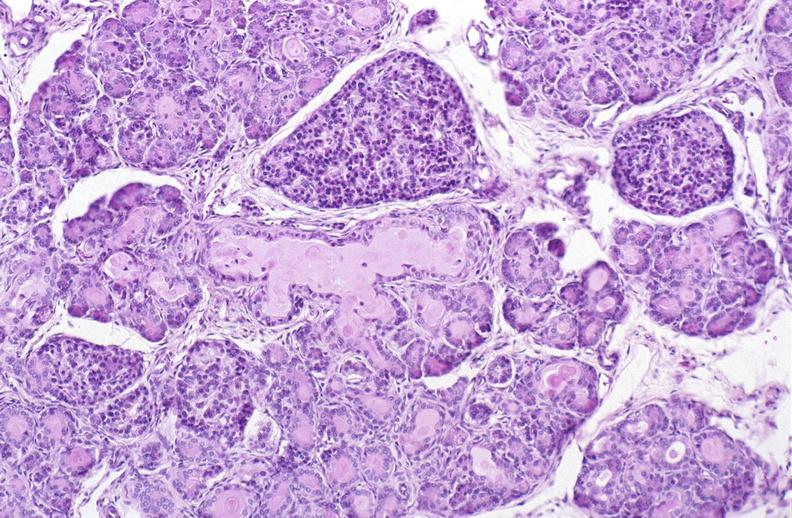s myomas present?
Answer the question using a single word or phrase. No 